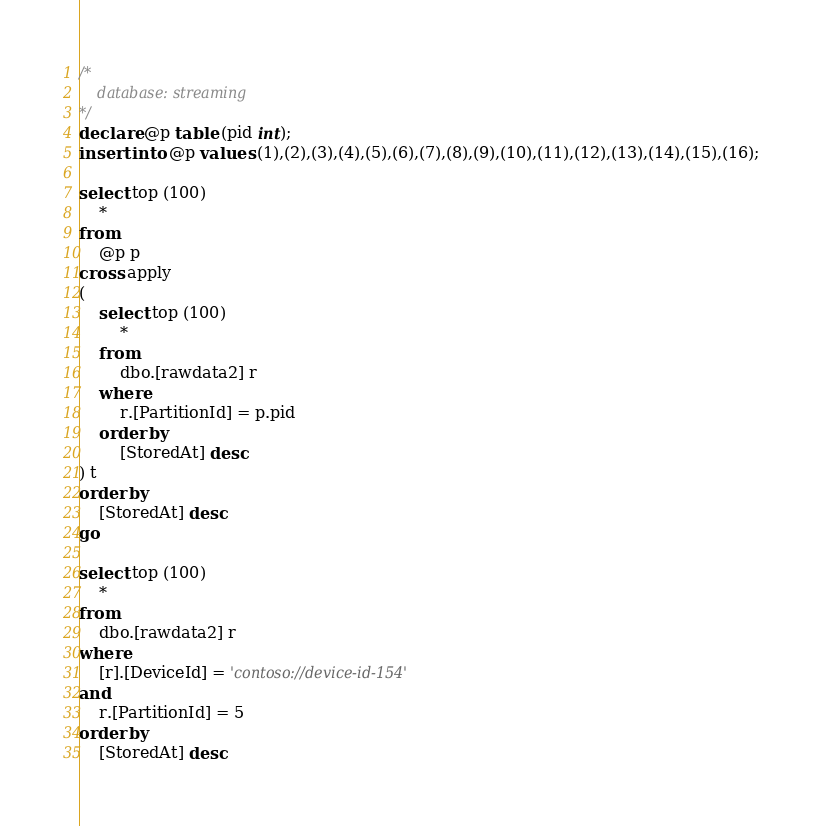Convert code to text. <code><loc_0><loc_0><loc_500><loc_500><_SQL_>/*
	database: streaming
*/
declare @p table (pid int);
insert into @p values (1),(2),(3),(4),(5),(6),(7),(8),(9),(10),(11),(12),(13),(14),(15),(16);

select top (100)
	*
from
	@p p
cross apply
(
	select top (100)
		*
	from
		dbo.[rawdata2] r
	where
		r.[PartitionId] = p.pid
	order by
		[StoredAt] desc
) t
order by
	[StoredAt] desc
go

select top (100)
	*
from
	dbo.[rawdata2] r
where
	[r].[DeviceId] = 'contoso://device-id-154'
and
	r.[PartitionId] = 5
order by
	[StoredAt] desc
</code> 